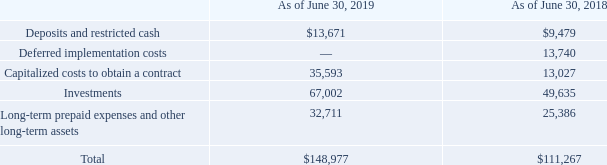NOTE 8—OTHER ASSETS
Deposits and restricted cash primarily relate to security deposits provided to landlords in accordance with facility lease agreements and cash restricted per the terms of certain contractual-based agreements.
Deferred implementation costs relate to direct and relevant costs on implementation of long-term contracts, to the extent such costs can be recovered through guaranteed contract revenues. As a result of the adoption of Topic 606, deferred implementation costs are no longer capitalized, but rather expensed as incurred as these costs do not relate to future performance obligations. Accordingly, these costs were adjusted through opening retained earnings as of July 1, 2018 (see note 3 "Revenues").
Capitalized costs to obtain a contract relate to incremental costs of obtaining a contract, such as sales commissions, which are eligible for capitalization on contracts to the extent that such costs are expected to be recovered (see note 3 "Revenues").
Investments relate to certain non-marketable equity securities in which we are a limited partner. Our interests in each of these investees range from 4% to below 20%. These investments are accounted for using the equity method. Our share of net income or losses based on our interest in these investments is recorded as a component of other income (expense), net in our Consolidated Statements of Income. During the year ended June 30, 2019, our share of income (loss) from these investments was $13.7 million (year ended June 30, 2018 and 2017 — $6.0 million and $6.0 million, respectively).
Long-term prepaid expenses and other long-term assets includes advance payments on long-term licenses that are being amortized over the applicable terms of the licenses and other miscellaneous assets.
What are Deposits and restricted cash primarily related to? Security deposits provided to landlords in accordance with facility lease agreements and cash restricted per the terms of certain contractual-based agreements. What is the result of the adoption of Topic 606? Deferred implementation costs are no longer capitalized, but rather expensed as incurred. What are the Fiscal years included in the table? 2019, 2018. What is the percentage difference of Deposits and restricted cash for June 30, 2019 vs June 30, 2018?
Answer scale should be: percent. (13,671-9,479)/9,479
Answer: 44.22. What is the Average annual total costs for both Fiscal years?
Answer scale should be: thousand. (148,977+111,267)/2
Answer: 130122. As of June 30, 2019, what is the Investment cost expressed as a percentage of total costs?
Answer scale should be: percent. 67,002/148,977
Answer: 44.97. 